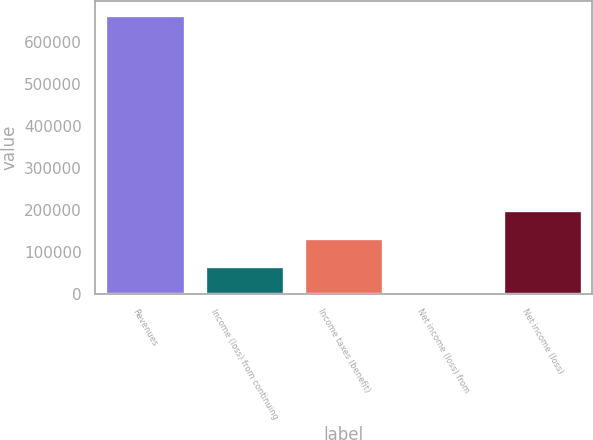<chart> <loc_0><loc_0><loc_500><loc_500><bar_chart><fcel>Revenues<fcel>Income (loss) from continuing<fcel>Income taxes (benefit)<fcel>Net income (loss) from<fcel>Net income (loss)<nl><fcel>663280<fcel>66524.2<fcel>132830<fcel>218<fcel>199137<nl></chart> 